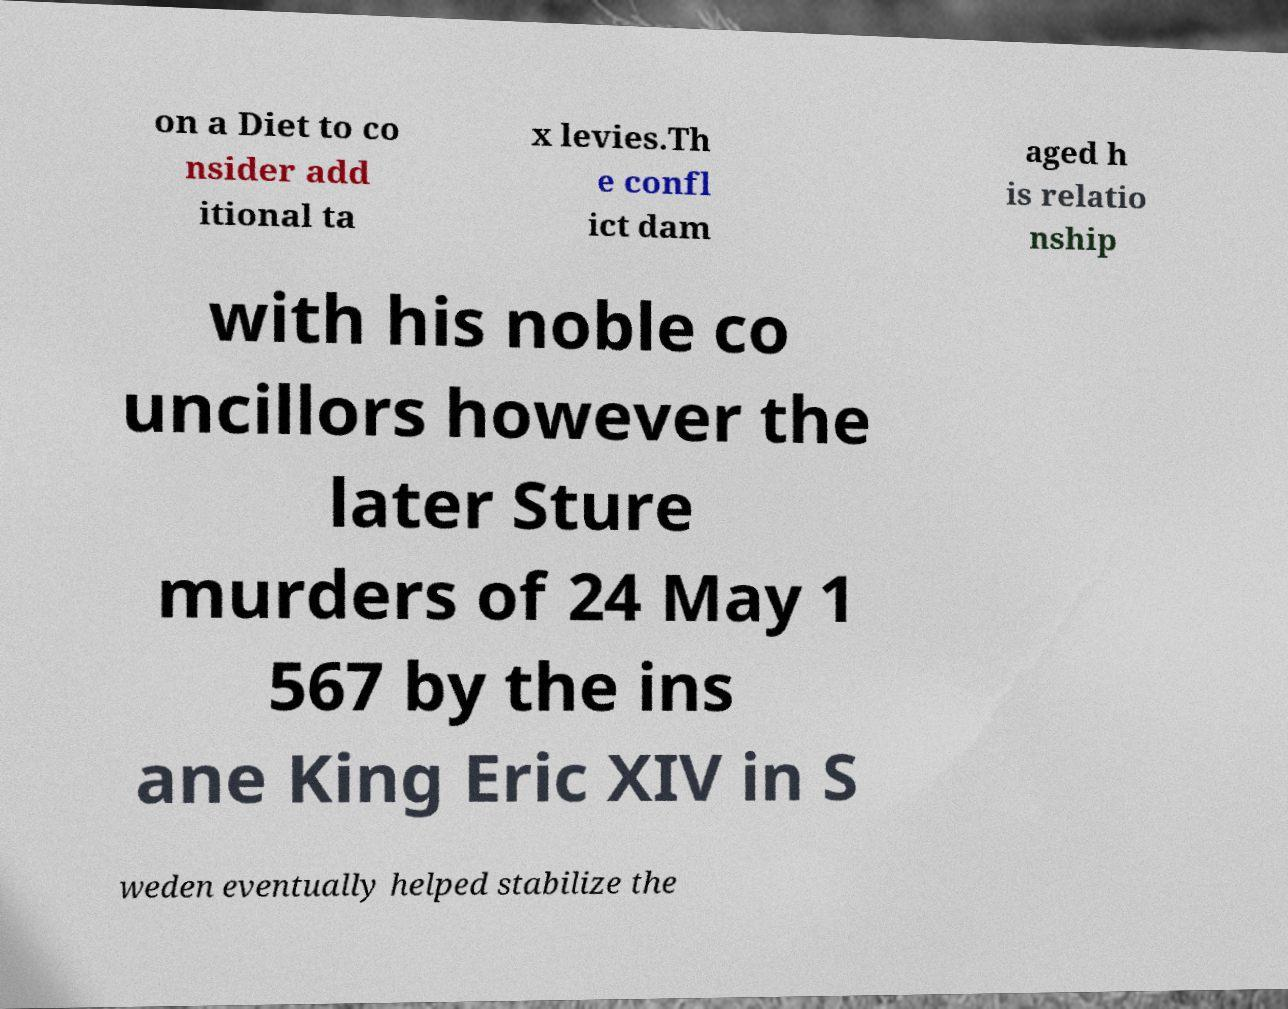There's text embedded in this image that I need extracted. Can you transcribe it verbatim? on a Diet to co nsider add itional ta x levies.Th e confl ict dam aged h is relatio nship with his noble co uncillors however the later Sture murders of 24 May 1 567 by the ins ane King Eric XIV in S weden eventually helped stabilize the 